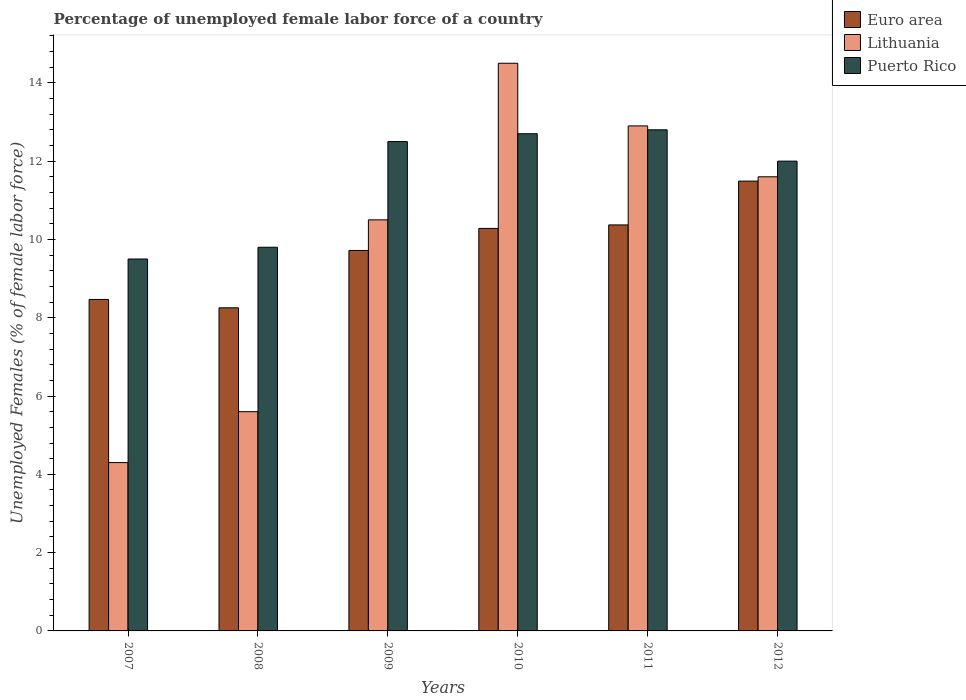How many groups of bars are there?
Make the answer very short. 6. How many bars are there on the 1st tick from the right?
Your response must be concise. 3. What is the percentage of unemployed female labor force in Euro area in 2007?
Offer a very short reply. 8.47. Across all years, what is the maximum percentage of unemployed female labor force in Euro area?
Ensure brevity in your answer.  11.49. Across all years, what is the minimum percentage of unemployed female labor force in Lithuania?
Give a very brief answer. 4.3. In which year was the percentage of unemployed female labor force in Puerto Rico maximum?
Keep it short and to the point. 2011. In which year was the percentage of unemployed female labor force in Euro area minimum?
Offer a terse response. 2008. What is the total percentage of unemployed female labor force in Euro area in the graph?
Ensure brevity in your answer.  58.58. What is the difference between the percentage of unemployed female labor force in Euro area in 2010 and that in 2011?
Offer a terse response. -0.09. What is the difference between the percentage of unemployed female labor force in Puerto Rico in 2008 and the percentage of unemployed female labor force in Lithuania in 2009?
Give a very brief answer. -0.7. What is the average percentage of unemployed female labor force in Lithuania per year?
Ensure brevity in your answer.  9.9. In the year 2008, what is the difference between the percentage of unemployed female labor force in Euro area and percentage of unemployed female labor force in Puerto Rico?
Ensure brevity in your answer.  -1.55. In how many years, is the percentage of unemployed female labor force in Euro area greater than 12.8 %?
Give a very brief answer. 0. What is the ratio of the percentage of unemployed female labor force in Euro area in 2007 to that in 2010?
Your answer should be very brief. 0.82. Is the percentage of unemployed female labor force in Puerto Rico in 2007 less than that in 2011?
Offer a very short reply. Yes. Is the difference between the percentage of unemployed female labor force in Euro area in 2008 and 2012 greater than the difference between the percentage of unemployed female labor force in Puerto Rico in 2008 and 2012?
Offer a terse response. No. What is the difference between the highest and the second highest percentage of unemployed female labor force in Euro area?
Ensure brevity in your answer.  1.12. What is the difference between the highest and the lowest percentage of unemployed female labor force in Lithuania?
Provide a short and direct response. 10.2. In how many years, is the percentage of unemployed female labor force in Lithuania greater than the average percentage of unemployed female labor force in Lithuania taken over all years?
Make the answer very short. 4. What does the 2nd bar from the left in 2007 represents?
Keep it short and to the point. Lithuania. Is it the case that in every year, the sum of the percentage of unemployed female labor force in Euro area and percentage of unemployed female labor force in Lithuania is greater than the percentage of unemployed female labor force in Puerto Rico?
Your answer should be very brief. Yes. How many bars are there?
Offer a very short reply. 18. What is the difference between two consecutive major ticks on the Y-axis?
Give a very brief answer. 2. Are the values on the major ticks of Y-axis written in scientific E-notation?
Your response must be concise. No. Where does the legend appear in the graph?
Ensure brevity in your answer.  Top right. How many legend labels are there?
Give a very brief answer. 3. What is the title of the graph?
Ensure brevity in your answer.  Percentage of unemployed female labor force of a country. What is the label or title of the Y-axis?
Keep it short and to the point. Unemployed Females (% of female labor force). What is the Unemployed Females (% of female labor force) of Euro area in 2007?
Your answer should be compact. 8.47. What is the Unemployed Females (% of female labor force) of Lithuania in 2007?
Your answer should be very brief. 4.3. What is the Unemployed Females (% of female labor force) in Euro area in 2008?
Give a very brief answer. 8.25. What is the Unemployed Females (% of female labor force) in Lithuania in 2008?
Give a very brief answer. 5.6. What is the Unemployed Females (% of female labor force) in Puerto Rico in 2008?
Keep it short and to the point. 9.8. What is the Unemployed Females (% of female labor force) in Euro area in 2009?
Your answer should be compact. 9.72. What is the Unemployed Females (% of female labor force) in Lithuania in 2009?
Ensure brevity in your answer.  10.5. What is the Unemployed Females (% of female labor force) of Puerto Rico in 2009?
Make the answer very short. 12.5. What is the Unemployed Females (% of female labor force) in Euro area in 2010?
Provide a short and direct response. 10.28. What is the Unemployed Females (% of female labor force) in Lithuania in 2010?
Your response must be concise. 14.5. What is the Unemployed Females (% of female labor force) of Puerto Rico in 2010?
Offer a terse response. 12.7. What is the Unemployed Females (% of female labor force) of Euro area in 2011?
Offer a terse response. 10.37. What is the Unemployed Females (% of female labor force) of Lithuania in 2011?
Provide a short and direct response. 12.9. What is the Unemployed Females (% of female labor force) in Puerto Rico in 2011?
Your answer should be compact. 12.8. What is the Unemployed Females (% of female labor force) of Euro area in 2012?
Provide a succinct answer. 11.49. What is the Unemployed Females (% of female labor force) in Lithuania in 2012?
Ensure brevity in your answer.  11.6. Across all years, what is the maximum Unemployed Females (% of female labor force) of Euro area?
Provide a short and direct response. 11.49. Across all years, what is the maximum Unemployed Females (% of female labor force) in Puerto Rico?
Ensure brevity in your answer.  12.8. Across all years, what is the minimum Unemployed Females (% of female labor force) of Euro area?
Ensure brevity in your answer.  8.25. Across all years, what is the minimum Unemployed Females (% of female labor force) in Lithuania?
Offer a terse response. 4.3. What is the total Unemployed Females (% of female labor force) in Euro area in the graph?
Offer a very short reply. 58.58. What is the total Unemployed Females (% of female labor force) in Lithuania in the graph?
Offer a terse response. 59.4. What is the total Unemployed Females (% of female labor force) in Puerto Rico in the graph?
Your answer should be very brief. 69.3. What is the difference between the Unemployed Females (% of female labor force) of Euro area in 2007 and that in 2008?
Provide a succinct answer. 0.21. What is the difference between the Unemployed Females (% of female labor force) of Lithuania in 2007 and that in 2008?
Your answer should be very brief. -1.3. What is the difference between the Unemployed Females (% of female labor force) of Puerto Rico in 2007 and that in 2008?
Your answer should be compact. -0.3. What is the difference between the Unemployed Females (% of female labor force) in Euro area in 2007 and that in 2009?
Provide a short and direct response. -1.25. What is the difference between the Unemployed Females (% of female labor force) in Lithuania in 2007 and that in 2009?
Provide a succinct answer. -6.2. What is the difference between the Unemployed Females (% of female labor force) of Euro area in 2007 and that in 2010?
Give a very brief answer. -1.81. What is the difference between the Unemployed Females (% of female labor force) in Lithuania in 2007 and that in 2010?
Your answer should be compact. -10.2. What is the difference between the Unemployed Females (% of female labor force) in Puerto Rico in 2007 and that in 2010?
Your response must be concise. -3.2. What is the difference between the Unemployed Females (% of female labor force) of Euro area in 2007 and that in 2011?
Keep it short and to the point. -1.9. What is the difference between the Unemployed Females (% of female labor force) of Puerto Rico in 2007 and that in 2011?
Your answer should be very brief. -3.3. What is the difference between the Unemployed Females (% of female labor force) in Euro area in 2007 and that in 2012?
Your answer should be compact. -3.02. What is the difference between the Unemployed Females (% of female labor force) of Lithuania in 2007 and that in 2012?
Ensure brevity in your answer.  -7.3. What is the difference between the Unemployed Females (% of female labor force) of Euro area in 2008 and that in 2009?
Make the answer very short. -1.47. What is the difference between the Unemployed Females (% of female labor force) of Puerto Rico in 2008 and that in 2009?
Your response must be concise. -2.7. What is the difference between the Unemployed Females (% of female labor force) in Euro area in 2008 and that in 2010?
Keep it short and to the point. -2.03. What is the difference between the Unemployed Females (% of female labor force) of Lithuania in 2008 and that in 2010?
Offer a very short reply. -8.9. What is the difference between the Unemployed Females (% of female labor force) in Puerto Rico in 2008 and that in 2010?
Offer a very short reply. -2.9. What is the difference between the Unemployed Females (% of female labor force) of Euro area in 2008 and that in 2011?
Give a very brief answer. -2.12. What is the difference between the Unemployed Females (% of female labor force) of Lithuania in 2008 and that in 2011?
Make the answer very short. -7.3. What is the difference between the Unemployed Females (% of female labor force) of Euro area in 2008 and that in 2012?
Offer a terse response. -3.24. What is the difference between the Unemployed Females (% of female labor force) of Lithuania in 2008 and that in 2012?
Offer a very short reply. -6. What is the difference between the Unemployed Females (% of female labor force) in Euro area in 2009 and that in 2010?
Your response must be concise. -0.56. What is the difference between the Unemployed Females (% of female labor force) in Puerto Rico in 2009 and that in 2010?
Offer a very short reply. -0.2. What is the difference between the Unemployed Females (% of female labor force) of Euro area in 2009 and that in 2011?
Provide a short and direct response. -0.65. What is the difference between the Unemployed Females (% of female labor force) of Lithuania in 2009 and that in 2011?
Your answer should be very brief. -2.4. What is the difference between the Unemployed Females (% of female labor force) in Puerto Rico in 2009 and that in 2011?
Offer a very short reply. -0.3. What is the difference between the Unemployed Females (% of female labor force) in Euro area in 2009 and that in 2012?
Keep it short and to the point. -1.77. What is the difference between the Unemployed Females (% of female labor force) of Puerto Rico in 2009 and that in 2012?
Make the answer very short. 0.5. What is the difference between the Unemployed Females (% of female labor force) of Euro area in 2010 and that in 2011?
Keep it short and to the point. -0.09. What is the difference between the Unemployed Females (% of female labor force) of Lithuania in 2010 and that in 2011?
Your answer should be very brief. 1.6. What is the difference between the Unemployed Females (% of female labor force) of Puerto Rico in 2010 and that in 2011?
Your response must be concise. -0.1. What is the difference between the Unemployed Females (% of female labor force) of Euro area in 2010 and that in 2012?
Keep it short and to the point. -1.21. What is the difference between the Unemployed Females (% of female labor force) of Lithuania in 2010 and that in 2012?
Give a very brief answer. 2.9. What is the difference between the Unemployed Females (% of female labor force) of Euro area in 2011 and that in 2012?
Your answer should be compact. -1.12. What is the difference between the Unemployed Females (% of female labor force) of Lithuania in 2011 and that in 2012?
Make the answer very short. 1.3. What is the difference between the Unemployed Females (% of female labor force) of Euro area in 2007 and the Unemployed Females (% of female labor force) of Lithuania in 2008?
Your response must be concise. 2.87. What is the difference between the Unemployed Females (% of female labor force) of Euro area in 2007 and the Unemployed Females (% of female labor force) of Puerto Rico in 2008?
Offer a very short reply. -1.33. What is the difference between the Unemployed Females (% of female labor force) of Euro area in 2007 and the Unemployed Females (% of female labor force) of Lithuania in 2009?
Offer a terse response. -2.03. What is the difference between the Unemployed Females (% of female labor force) in Euro area in 2007 and the Unemployed Females (% of female labor force) in Puerto Rico in 2009?
Provide a short and direct response. -4.03. What is the difference between the Unemployed Females (% of female labor force) of Lithuania in 2007 and the Unemployed Females (% of female labor force) of Puerto Rico in 2009?
Give a very brief answer. -8.2. What is the difference between the Unemployed Females (% of female labor force) in Euro area in 2007 and the Unemployed Females (% of female labor force) in Lithuania in 2010?
Give a very brief answer. -6.03. What is the difference between the Unemployed Females (% of female labor force) in Euro area in 2007 and the Unemployed Females (% of female labor force) in Puerto Rico in 2010?
Offer a very short reply. -4.23. What is the difference between the Unemployed Females (% of female labor force) of Lithuania in 2007 and the Unemployed Females (% of female labor force) of Puerto Rico in 2010?
Keep it short and to the point. -8.4. What is the difference between the Unemployed Females (% of female labor force) of Euro area in 2007 and the Unemployed Females (% of female labor force) of Lithuania in 2011?
Ensure brevity in your answer.  -4.43. What is the difference between the Unemployed Females (% of female labor force) of Euro area in 2007 and the Unemployed Females (% of female labor force) of Puerto Rico in 2011?
Offer a very short reply. -4.33. What is the difference between the Unemployed Females (% of female labor force) in Lithuania in 2007 and the Unemployed Females (% of female labor force) in Puerto Rico in 2011?
Provide a succinct answer. -8.5. What is the difference between the Unemployed Females (% of female labor force) in Euro area in 2007 and the Unemployed Females (% of female labor force) in Lithuania in 2012?
Your answer should be compact. -3.13. What is the difference between the Unemployed Females (% of female labor force) of Euro area in 2007 and the Unemployed Females (% of female labor force) of Puerto Rico in 2012?
Provide a short and direct response. -3.53. What is the difference between the Unemployed Females (% of female labor force) in Euro area in 2008 and the Unemployed Females (% of female labor force) in Lithuania in 2009?
Your answer should be very brief. -2.25. What is the difference between the Unemployed Females (% of female labor force) of Euro area in 2008 and the Unemployed Females (% of female labor force) of Puerto Rico in 2009?
Offer a very short reply. -4.25. What is the difference between the Unemployed Females (% of female labor force) of Euro area in 2008 and the Unemployed Females (% of female labor force) of Lithuania in 2010?
Ensure brevity in your answer.  -6.25. What is the difference between the Unemployed Females (% of female labor force) in Euro area in 2008 and the Unemployed Females (% of female labor force) in Puerto Rico in 2010?
Provide a short and direct response. -4.45. What is the difference between the Unemployed Females (% of female labor force) of Euro area in 2008 and the Unemployed Females (% of female labor force) of Lithuania in 2011?
Offer a terse response. -4.65. What is the difference between the Unemployed Females (% of female labor force) in Euro area in 2008 and the Unemployed Females (% of female labor force) in Puerto Rico in 2011?
Your response must be concise. -4.55. What is the difference between the Unemployed Females (% of female labor force) in Euro area in 2008 and the Unemployed Females (% of female labor force) in Lithuania in 2012?
Give a very brief answer. -3.35. What is the difference between the Unemployed Females (% of female labor force) in Euro area in 2008 and the Unemployed Females (% of female labor force) in Puerto Rico in 2012?
Your answer should be very brief. -3.75. What is the difference between the Unemployed Females (% of female labor force) of Euro area in 2009 and the Unemployed Females (% of female labor force) of Lithuania in 2010?
Your response must be concise. -4.78. What is the difference between the Unemployed Females (% of female labor force) in Euro area in 2009 and the Unemployed Females (% of female labor force) in Puerto Rico in 2010?
Provide a succinct answer. -2.98. What is the difference between the Unemployed Females (% of female labor force) of Lithuania in 2009 and the Unemployed Females (% of female labor force) of Puerto Rico in 2010?
Your answer should be compact. -2.2. What is the difference between the Unemployed Females (% of female labor force) in Euro area in 2009 and the Unemployed Females (% of female labor force) in Lithuania in 2011?
Your answer should be very brief. -3.18. What is the difference between the Unemployed Females (% of female labor force) of Euro area in 2009 and the Unemployed Females (% of female labor force) of Puerto Rico in 2011?
Your response must be concise. -3.08. What is the difference between the Unemployed Females (% of female labor force) in Euro area in 2009 and the Unemployed Females (% of female labor force) in Lithuania in 2012?
Your response must be concise. -1.88. What is the difference between the Unemployed Females (% of female labor force) in Euro area in 2009 and the Unemployed Females (% of female labor force) in Puerto Rico in 2012?
Keep it short and to the point. -2.28. What is the difference between the Unemployed Females (% of female labor force) of Lithuania in 2009 and the Unemployed Females (% of female labor force) of Puerto Rico in 2012?
Offer a terse response. -1.5. What is the difference between the Unemployed Females (% of female labor force) in Euro area in 2010 and the Unemployed Females (% of female labor force) in Lithuania in 2011?
Your answer should be very brief. -2.62. What is the difference between the Unemployed Females (% of female labor force) of Euro area in 2010 and the Unemployed Females (% of female labor force) of Puerto Rico in 2011?
Offer a very short reply. -2.52. What is the difference between the Unemployed Females (% of female labor force) in Euro area in 2010 and the Unemployed Females (% of female labor force) in Lithuania in 2012?
Ensure brevity in your answer.  -1.32. What is the difference between the Unemployed Females (% of female labor force) in Euro area in 2010 and the Unemployed Females (% of female labor force) in Puerto Rico in 2012?
Make the answer very short. -1.72. What is the difference between the Unemployed Females (% of female labor force) in Euro area in 2011 and the Unemployed Females (% of female labor force) in Lithuania in 2012?
Provide a short and direct response. -1.23. What is the difference between the Unemployed Females (% of female labor force) in Euro area in 2011 and the Unemployed Females (% of female labor force) in Puerto Rico in 2012?
Provide a succinct answer. -1.63. What is the difference between the Unemployed Females (% of female labor force) in Lithuania in 2011 and the Unemployed Females (% of female labor force) in Puerto Rico in 2012?
Make the answer very short. 0.9. What is the average Unemployed Females (% of female labor force) in Euro area per year?
Give a very brief answer. 9.76. What is the average Unemployed Females (% of female labor force) of Puerto Rico per year?
Give a very brief answer. 11.55. In the year 2007, what is the difference between the Unemployed Females (% of female labor force) of Euro area and Unemployed Females (% of female labor force) of Lithuania?
Provide a succinct answer. 4.17. In the year 2007, what is the difference between the Unemployed Females (% of female labor force) in Euro area and Unemployed Females (% of female labor force) in Puerto Rico?
Provide a succinct answer. -1.03. In the year 2007, what is the difference between the Unemployed Females (% of female labor force) in Lithuania and Unemployed Females (% of female labor force) in Puerto Rico?
Ensure brevity in your answer.  -5.2. In the year 2008, what is the difference between the Unemployed Females (% of female labor force) in Euro area and Unemployed Females (% of female labor force) in Lithuania?
Your answer should be very brief. 2.65. In the year 2008, what is the difference between the Unemployed Females (% of female labor force) in Euro area and Unemployed Females (% of female labor force) in Puerto Rico?
Your answer should be compact. -1.55. In the year 2008, what is the difference between the Unemployed Females (% of female labor force) of Lithuania and Unemployed Females (% of female labor force) of Puerto Rico?
Your answer should be compact. -4.2. In the year 2009, what is the difference between the Unemployed Females (% of female labor force) in Euro area and Unemployed Females (% of female labor force) in Lithuania?
Provide a short and direct response. -0.78. In the year 2009, what is the difference between the Unemployed Females (% of female labor force) in Euro area and Unemployed Females (% of female labor force) in Puerto Rico?
Make the answer very short. -2.78. In the year 2009, what is the difference between the Unemployed Females (% of female labor force) of Lithuania and Unemployed Females (% of female labor force) of Puerto Rico?
Give a very brief answer. -2. In the year 2010, what is the difference between the Unemployed Females (% of female labor force) of Euro area and Unemployed Females (% of female labor force) of Lithuania?
Offer a terse response. -4.22. In the year 2010, what is the difference between the Unemployed Females (% of female labor force) in Euro area and Unemployed Females (% of female labor force) in Puerto Rico?
Your answer should be compact. -2.42. In the year 2011, what is the difference between the Unemployed Females (% of female labor force) in Euro area and Unemployed Females (% of female labor force) in Lithuania?
Provide a succinct answer. -2.53. In the year 2011, what is the difference between the Unemployed Females (% of female labor force) in Euro area and Unemployed Females (% of female labor force) in Puerto Rico?
Make the answer very short. -2.43. In the year 2012, what is the difference between the Unemployed Females (% of female labor force) in Euro area and Unemployed Females (% of female labor force) in Lithuania?
Ensure brevity in your answer.  -0.11. In the year 2012, what is the difference between the Unemployed Females (% of female labor force) of Euro area and Unemployed Females (% of female labor force) of Puerto Rico?
Keep it short and to the point. -0.51. What is the ratio of the Unemployed Females (% of female labor force) of Euro area in 2007 to that in 2008?
Give a very brief answer. 1.03. What is the ratio of the Unemployed Females (% of female labor force) in Lithuania in 2007 to that in 2008?
Your answer should be very brief. 0.77. What is the ratio of the Unemployed Females (% of female labor force) in Puerto Rico in 2007 to that in 2008?
Offer a terse response. 0.97. What is the ratio of the Unemployed Females (% of female labor force) of Euro area in 2007 to that in 2009?
Offer a very short reply. 0.87. What is the ratio of the Unemployed Females (% of female labor force) in Lithuania in 2007 to that in 2009?
Make the answer very short. 0.41. What is the ratio of the Unemployed Females (% of female labor force) in Puerto Rico in 2007 to that in 2009?
Make the answer very short. 0.76. What is the ratio of the Unemployed Females (% of female labor force) in Euro area in 2007 to that in 2010?
Keep it short and to the point. 0.82. What is the ratio of the Unemployed Females (% of female labor force) of Lithuania in 2007 to that in 2010?
Ensure brevity in your answer.  0.3. What is the ratio of the Unemployed Females (% of female labor force) in Puerto Rico in 2007 to that in 2010?
Give a very brief answer. 0.75. What is the ratio of the Unemployed Females (% of female labor force) in Euro area in 2007 to that in 2011?
Your answer should be very brief. 0.82. What is the ratio of the Unemployed Females (% of female labor force) of Puerto Rico in 2007 to that in 2011?
Give a very brief answer. 0.74. What is the ratio of the Unemployed Females (% of female labor force) of Euro area in 2007 to that in 2012?
Keep it short and to the point. 0.74. What is the ratio of the Unemployed Females (% of female labor force) of Lithuania in 2007 to that in 2012?
Make the answer very short. 0.37. What is the ratio of the Unemployed Females (% of female labor force) in Puerto Rico in 2007 to that in 2012?
Your response must be concise. 0.79. What is the ratio of the Unemployed Females (% of female labor force) of Euro area in 2008 to that in 2009?
Ensure brevity in your answer.  0.85. What is the ratio of the Unemployed Females (% of female labor force) in Lithuania in 2008 to that in 2009?
Provide a succinct answer. 0.53. What is the ratio of the Unemployed Females (% of female labor force) of Puerto Rico in 2008 to that in 2009?
Your answer should be very brief. 0.78. What is the ratio of the Unemployed Females (% of female labor force) of Euro area in 2008 to that in 2010?
Give a very brief answer. 0.8. What is the ratio of the Unemployed Females (% of female labor force) of Lithuania in 2008 to that in 2010?
Make the answer very short. 0.39. What is the ratio of the Unemployed Females (% of female labor force) of Puerto Rico in 2008 to that in 2010?
Offer a terse response. 0.77. What is the ratio of the Unemployed Females (% of female labor force) of Euro area in 2008 to that in 2011?
Your response must be concise. 0.8. What is the ratio of the Unemployed Females (% of female labor force) of Lithuania in 2008 to that in 2011?
Offer a very short reply. 0.43. What is the ratio of the Unemployed Females (% of female labor force) in Puerto Rico in 2008 to that in 2011?
Provide a succinct answer. 0.77. What is the ratio of the Unemployed Females (% of female labor force) in Euro area in 2008 to that in 2012?
Your answer should be very brief. 0.72. What is the ratio of the Unemployed Females (% of female labor force) of Lithuania in 2008 to that in 2012?
Provide a succinct answer. 0.48. What is the ratio of the Unemployed Females (% of female labor force) in Puerto Rico in 2008 to that in 2012?
Keep it short and to the point. 0.82. What is the ratio of the Unemployed Females (% of female labor force) in Euro area in 2009 to that in 2010?
Your response must be concise. 0.95. What is the ratio of the Unemployed Females (% of female labor force) in Lithuania in 2009 to that in 2010?
Offer a terse response. 0.72. What is the ratio of the Unemployed Females (% of female labor force) in Puerto Rico in 2009 to that in 2010?
Offer a terse response. 0.98. What is the ratio of the Unemployed Females (% of female labor force) of Euro area in 2009 to that in 2011?
Make the answer very short. 0.94. What is the ratio of the Unemployed Females (% of female labor force) in Lithuania in 2009 to that in 2011?
Your response must be concise. 0.81. What is the ratio of the Unemployed Females (% of female labor force) of Puerto Rico in 2009 to that in 2011?
Ensure brevity in your answer.  0.98. What is the ratio of the Unemployed Females (% of female labor force) in Euro area in 2009 to that in 2012?
Your answer should be very brief. 0.85. What is the ratio of the Unemployed Females (% of female labor force) of Lithuania in 2009 to that in 2012?
Your answer should be very brief. 0.91. What is the ratio of the Unemployed Females (% of female labor force) of Puerto Rico in 2009 to that in 2012?
Keep it short and to the point. 1.04. What is the ratio of the Unemployed Females (% of female labor force) of Euro area in 2010 to that in 2011?
Your response must be concise. 0.99. What is the ratio of the Unemployed Females (% of female labor force) in Lithuania in 2010 to that in 2011?
Offer a terse response. 1.12. What is the ratio of the Unemployed Females (% of female labor force) of Puerto Rico in 2010 to that in 2011?
Your answer should be compact. 0.99. What is the ratio of the Unemployed Females (% of female labor force) in Euro area in 2010 to that in 2012?
Make the answer very short. 0.89. What is the ratio of the Unemployed Females (% of female labor force) in Lithuania in 2010 to that in 2012?
Offer a terse response. 1.25. What is the ratio of the Unemployed Females (% of female labor force) in Puerto Rico in 2010 to that in 2012?
Your answer should be compact. 1.06. What is the ratio of the Unemployed Females (% of female labor force) in Euro area in 2011 to that in 2012?
Make the answer very short. 0.9. What is the ratio of the Unemployed Females (% of female labor force) of Lithuania in 2011 to that in 2012?
Your answer should be very brief. 1.11. What is the ratio of the Unemployed Females (% of female labor force) in Puerto Rico in 2011 to that in 2012?
Ensure brevity in your answer.  1.07. What is the difference between the highest and the second highest Unemployed Females (% of female labor force) in Euro area?
Provide a succinct answer. 1.12. What is the difference between the highest and the second highest Unemployed Females (% of female labor force) of Puerto Rico?
Provide a succinct answer. 0.1. What is the difference between the highest and the lowest Unemployed Females (% of female labor force) of Euro area?
Give a very brief answer. 3.24. What is the difference between the highest and the lowest Unemployed Females (% of female labor force) in Lithuania?
Ensure brevity in your answer.  10.2. 